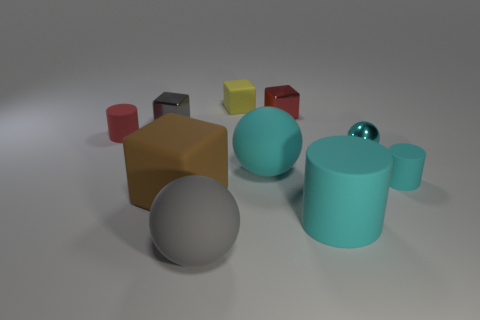Subtract all large spheres. How many spheres are left? 1 Subtract all cyan spheres. How many cyan cylinders are left? 2 Subtract 1 cylinders. How many cylinders are left? 2 Subtract all gray spheres. How many spheres are left? 2 Subtract all cubes. How many objects are left? 6 Subtract all green cubes. Subtract all green spheres. How many cubes are left? 4 Subtract all spheres. Subtract all big blue cubes. How many objects are left? 7 Add 2 brown blocks. How many brown blocks are left? 3 Add 3 big cyan cylinders. How many big cyan cylinders exist? 4 Subtract 1 gray spheres. How many objects are left? 9 